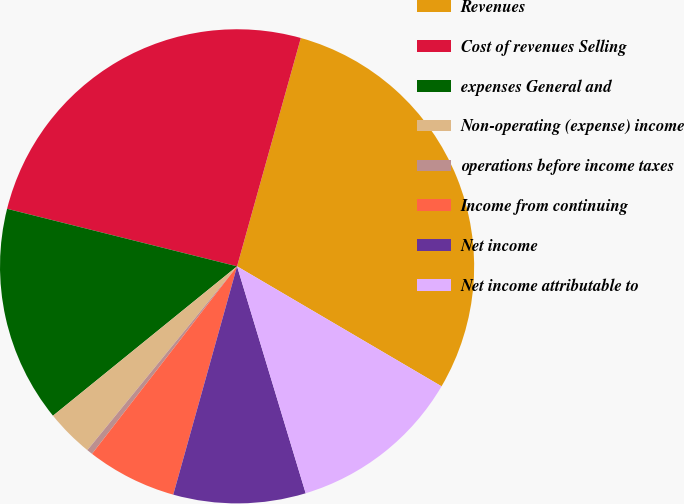Convert chart. <chart><loc_0><loc_0><loc_500><loc_500><pie_chart><fcel>Revenues<fcel>Cost of revenues Selling<fcel>expenses General and<fcel>Non-operating (expense) income<fcel>operations before income taxes<fcel>Income from continuing<fcel>Net income<fcel>Net income attributable to<nl><fcel>29.11%<fcel>25.43%<fcel>14.75%<fcel>3.27%<fcel>0.4%<fcel>6.14%<fcel>9.01%<fcel>11.88%<nl></chart> 